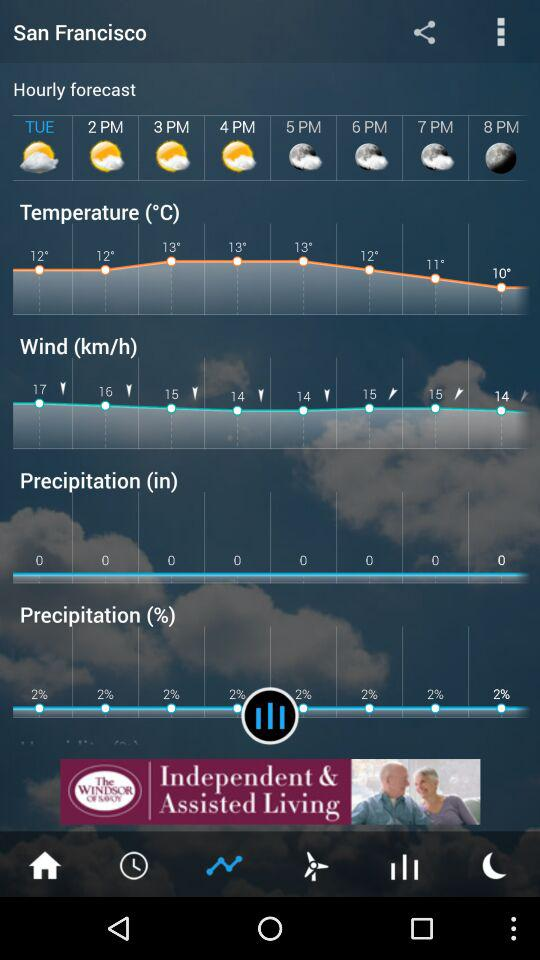What is the precipitation percentage? The precipitation percentage is 2. 